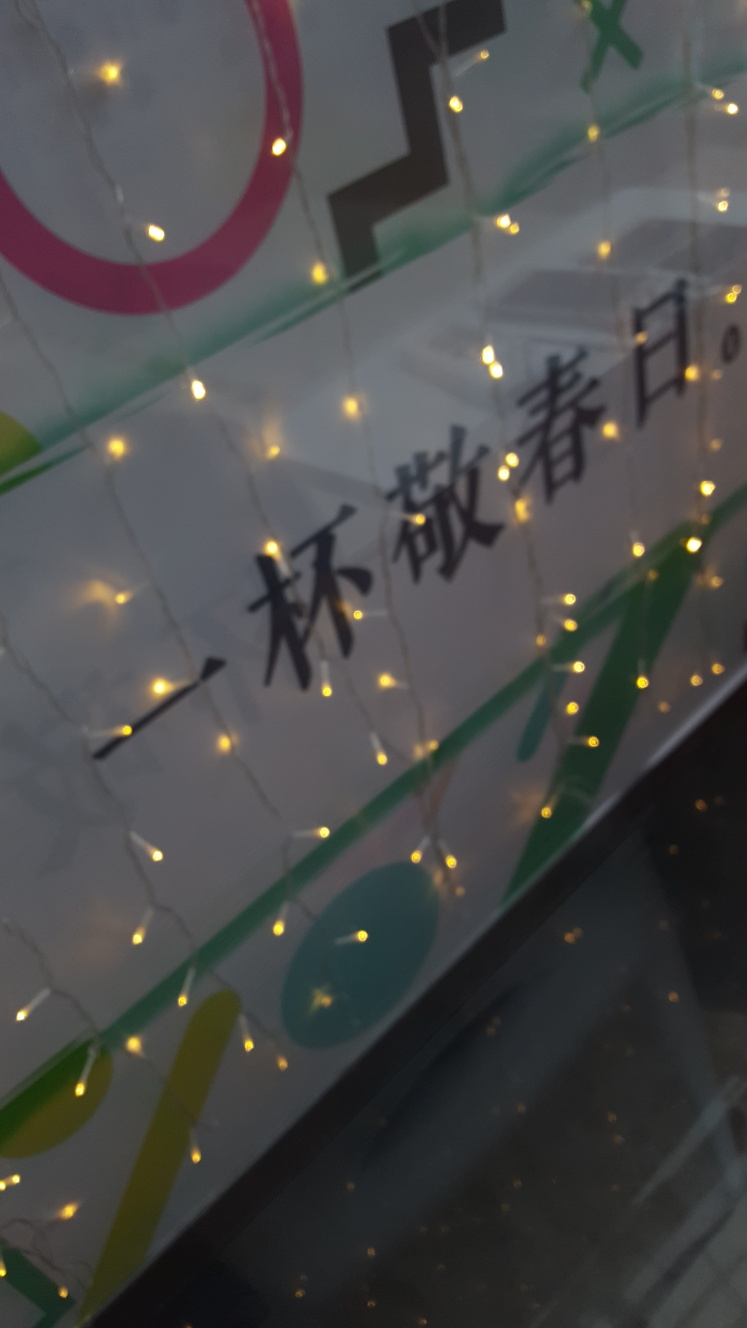Is the outline of the small light bulb blurry? Indeed, the outline of the small light bulb appears blurry. This is likely due to a shallow depth of field from the camera used to take the photo, causing only a specific area of the image to be in sharp focus. The blurriness adds a subtle bokeh effect to the lights, which can be aesthetically pleasing and is often used in photography to draw attention to a subject. 